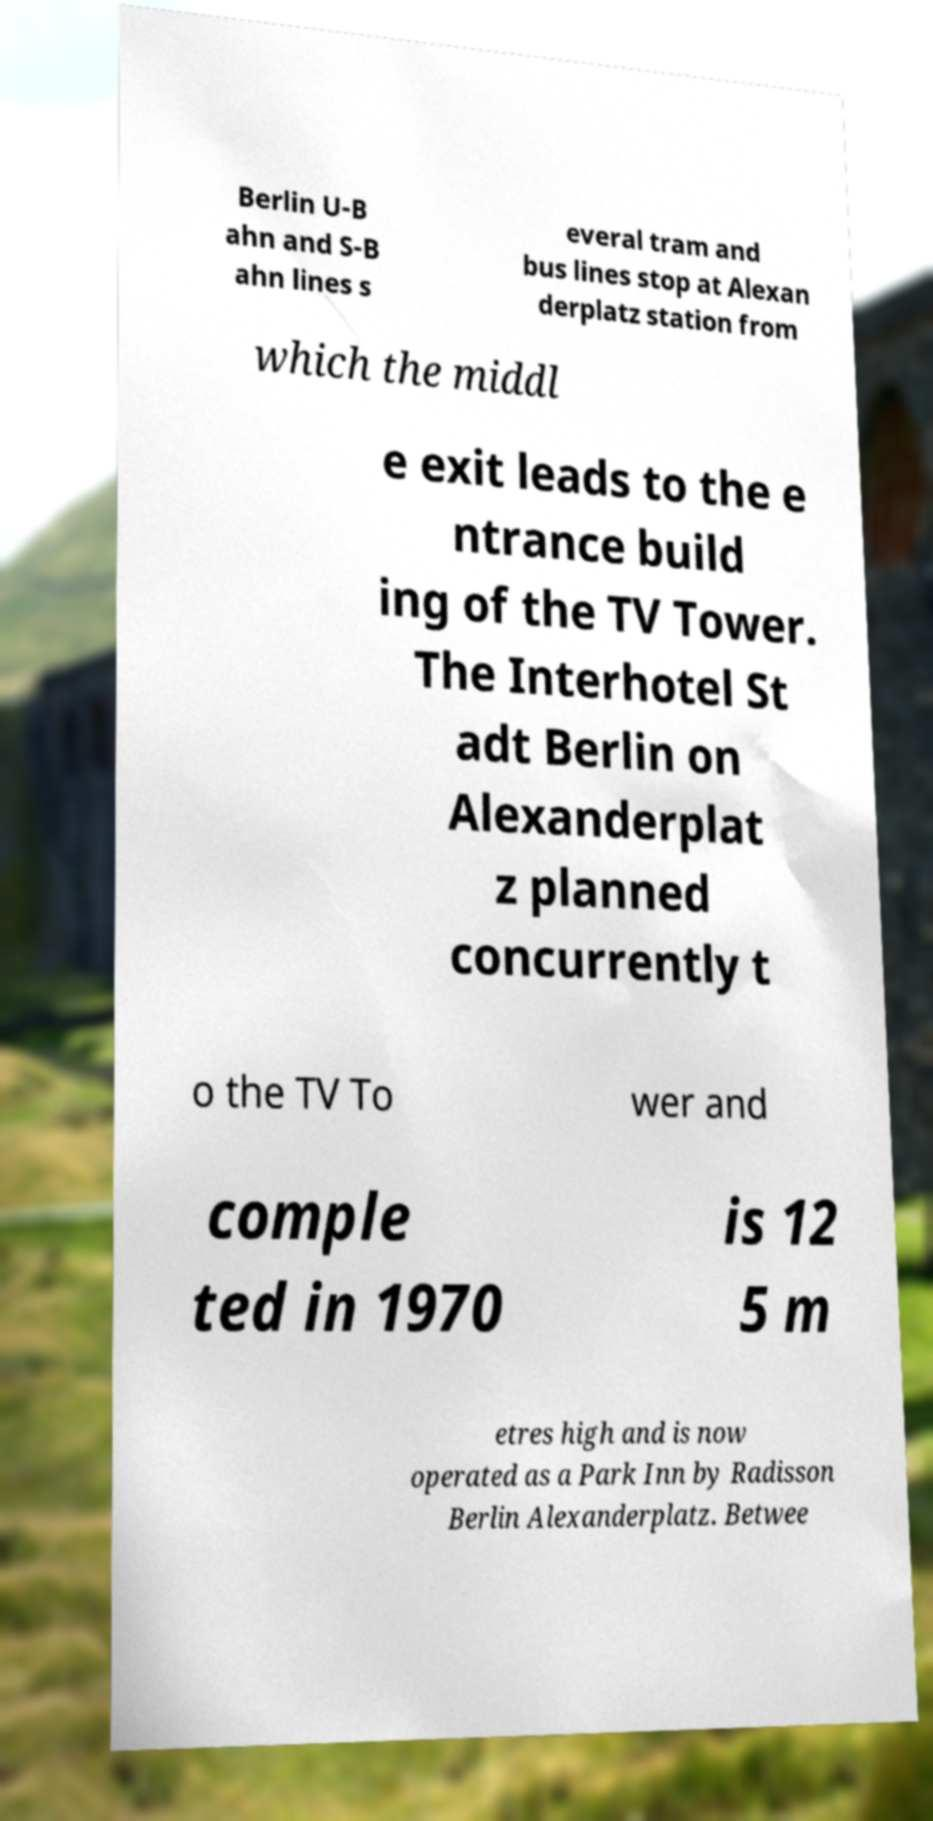Please identify and transcribe the text found in this image. Berlin U-B ahn and S-B ahn lines s everal tram and bus lines stop at Alexan derplatz station from which the middl e exit leads to the e ntrance build ing of the TV Tower. The Interhotel St adt Berlin on Alexanderplat z planned concurrently t o the TV To wer and comple ted in 1970 is 12 5 m etres high and is now operated as a Park Inn by Radisson Berlin Alexanderplatz. Betwee 